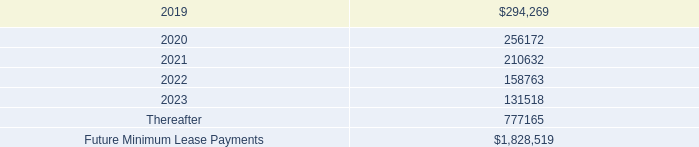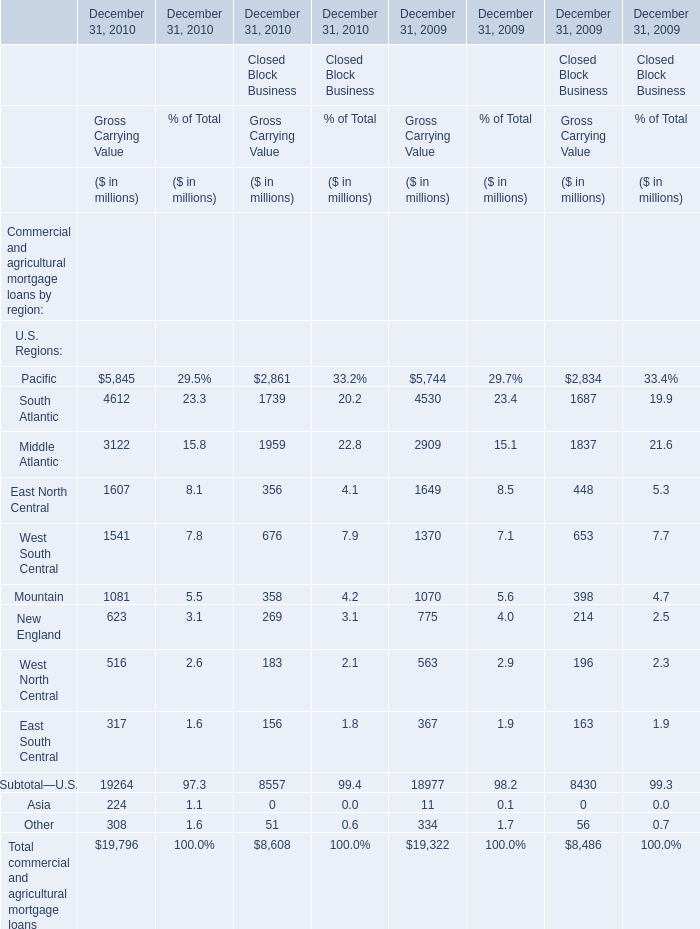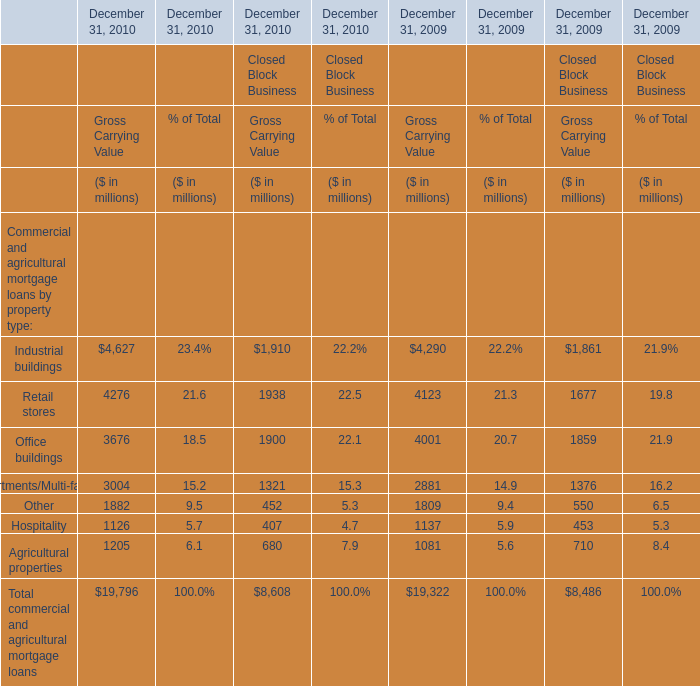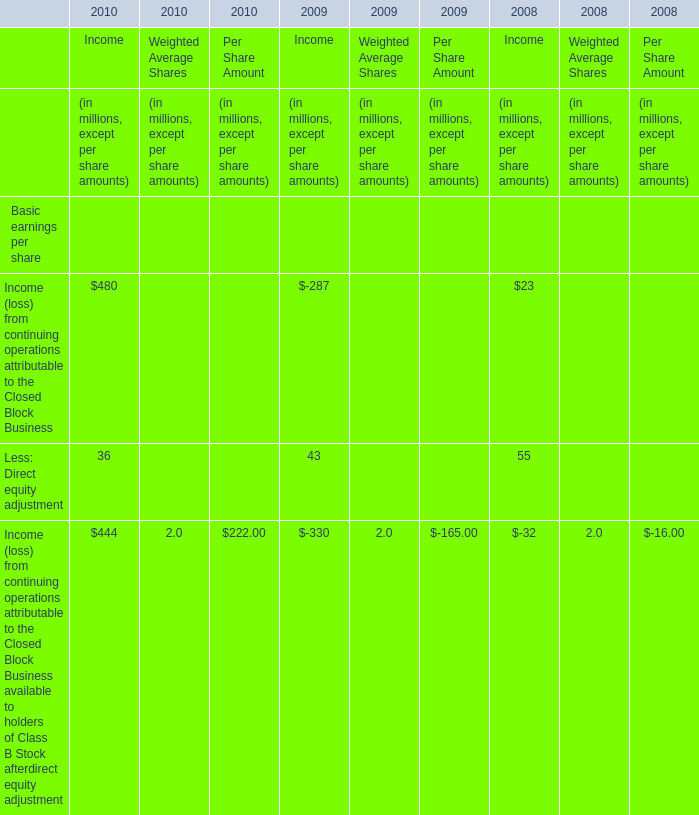what was the percentage change in rental expenses from 2017 to 2018? 
Computations: ((300 - 247) / 247)
Answer: 0.21457. 